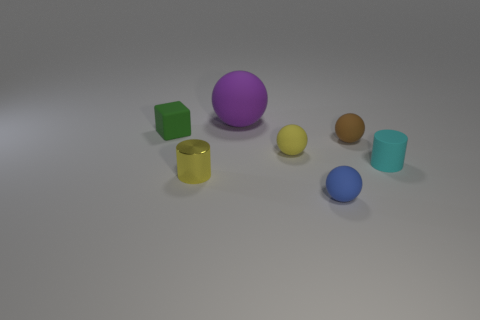Subtract all purple spheres. How many spheres are left? 3 Add 2 tiny yellow things. How many objects exist? 9 Subtract all cyan cylinders. How many cylinders are left? 1 Subtract all balls. How many objects are left? 3 Subtract 2 spheres. How many spheres are left? 2 Subtract all gray spheres. Subtract all gray cylinders. How many spheres are left? 4 Subtract all big blue rubber cubes. Subtract all tiny green matte cubes. How many objects are left? 6 Add 7 small green objects. How many small green objects are left? 8 Add 5 large purple objects. How many large purple objects exist? 6 Subtract 0 purple cylinders. How many objects are left? 7 